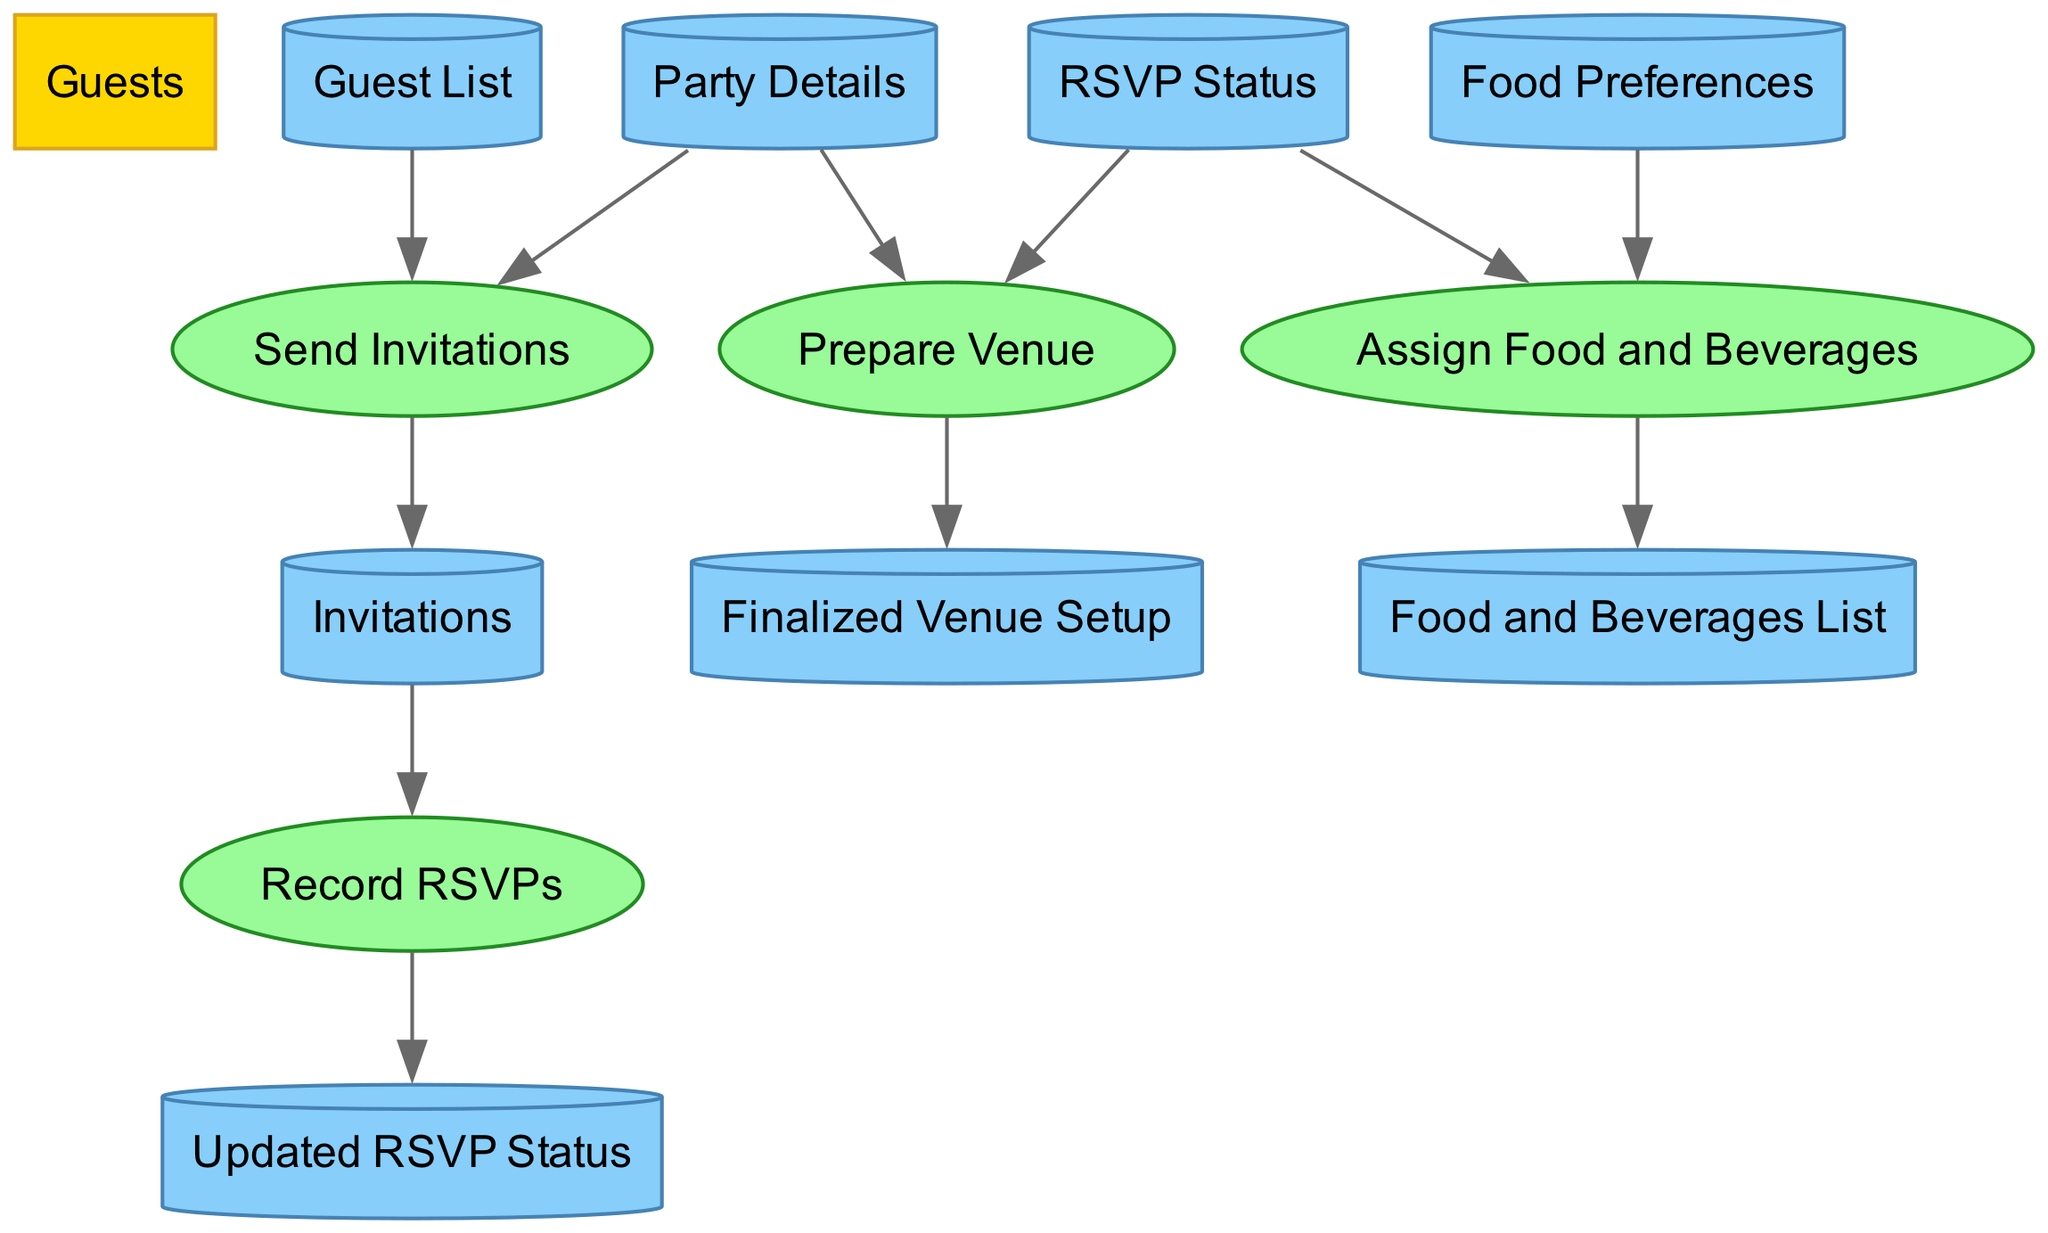What are the inputs for the "Send Invitations" process? The "Send Invitations" process takes two inputs: the "Guest List" and the "Party Details", as indicated by the arrows flowing into the process in the diagram.
Answer: Guest List, Party Details How many attributes does the "Guest" entity have? The "Guest" entity has five attributes listed under it in the diagram: Guest ID, Name, Favorite Team, Contact Information, and RSVP Status.
Answer: Five What are the outputs of the "Record RSVPs" process? The output of the "Record RSVPs" process is labeled as "Updated RSVP Status". This can be seen from the arrow pointing out of the process in the diagram.
Answer: Updated RSVP Status Which data store is related to RSVP responses? The data store related to RSVP responses is labeled "RSVP Status", which contains the attributes pertinent to tracking the responses given by guests.
Answer: RSVP Status What process uses "Food Preferences" as an input? The "Assign Food and Beverages" process utilizes "Food Preferences" as one of its inputs, as indicated in the diagram by the arrow leading into this process.
Answer: Assign Food and Beverages How many external entities are represented in the diagram? There is one external entity represented in the diagram, titled "Guests", highlighting the interaction point between the system and external individuals.
Answer: One Which attribute in the "Party Details" data store indicates the date of the party? The "Party Date" attribute in the "Party Details" data store indicates the date when the party is scheduled, as listed under the attributes for that entity.
Answer: Party Date Which process leads to the creation of "Invitations"? The "Send Invitations" process directly leads to the creation of "Invitations", as it is shown as the output in the diagram coming from this process.
Answer: Send Invitations How many inputs does the "Prepare Venue" process have? The "Prepare Venue" process has two inputs: "Party Details" and "RSVP Status", which are shown as the inputs feeding into this process in the diagram.
Answer: Two 